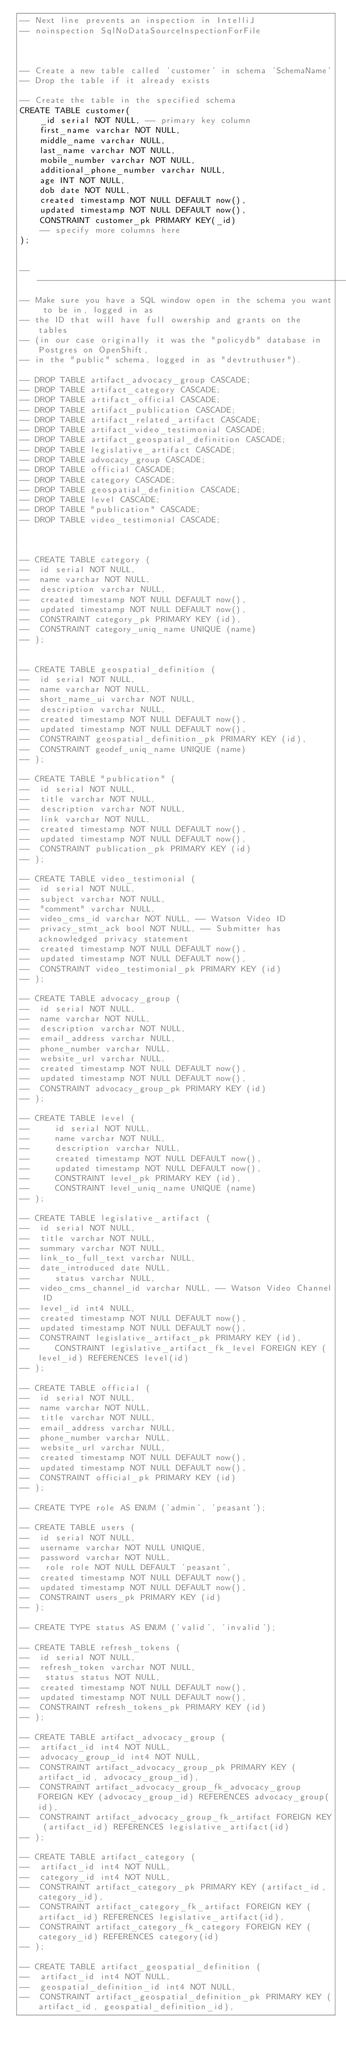<code> <loc_0><loc_0><loc_500><loc_500><_SQL_>-- Next line prevents an inspection in IntelliJ
-- noinspection SqlNoDataSourceInspectionForFile



-- Create a new table called 'customer' in schema 'SchemaName'
-- Drop the table if it already exists

-- Create the table in the specified schema
CREATE TABLE customer(
	_id serial NOT NULL, -- primary key column
	first_name varchar NOT NULL,
	middle_name varchar NULL,
	last_name varchar NOT NULL,
	mobile_number varchar NOT NULL,
	additional_phone_number varchar NULL,
	age INT NOT NULL,
	dob date NOT NULL,
	created timestamp NOT NULL DEFAULT now(),
	updated timestamp NOT NULL DEFAULT now(),
	CONSTRAINT customer_pk PRIMARY KEY(_id)
	-- specify more columns here
);


-- --------------------------------------------------------------------------------------------------------
-- Make sure you have a SQL window open in the schema you want to be in, logged in as
-- the ID that will have full owership and grants on the tables
-- (in our case originally it was the "policydb" database in Postgres on OpenShift,
-- in the "public" schema, logged in as "devtruthuser").

-- DROP TABLE artifact_advocacy_group CASCADE;
-- DROP TABLE artifact_category CASCADE;
-- DROP TABLE artifact_official CASCADE;
-- DROP TABLE artifact_publication CASCADE;
-- DROP TABLE artifact_related_artifact CASCADE;
-- DROP TABLE artifact_video_testimonial CASCADE;
-- DROP TABLE artifact_geospatial_definition CASCADE;
-- DROP TABLE legislative_artifact CASCADE;
-- DROP TABLE advocacy_group CASCADE;
-- DROP TABLE official CASCADE;
-- DROP TABLE category CASCADE;
-- DROP TABLE geospatial_definition CASCADE;
-- DROP TABLE level CASCADE;
-- DROP TABLE "publication" CASCADE;
-- DROP TABLE video_testimonial CASCADE;



-- CREATE TABLE category (
-- 	id serial NOT NULL,
-- 	name varchar NOT NULL,
-- 	description varchar NULL,
-- 	created timestamp NOT NULL DEFAULT now(),
-- 	updated timestamp NOT NULL DEFAULT now(),
-- 	CONSTRAINT category_pk PRIMARY KEY (id),
-- 	CONSTRAINT category_uniq_name UNIQUE (name)
-- );


-- CREATE TABLE geospatial_definition (
-- 	id serial NOT NULL,
-- 	name varchar NOT NULL,
-- 	short_name_ui varchar NOT NULL,
-- 	description varchar NULL,
-- 	created timestamp NOT NULL DEFAULT now(),
-- 	updated timestamp NOT NULL DEFAULT now(),
-- 	CONSTRAINT geospatial_definition_pk PRIMARY KEY (id),
-- 	CONSTRAINT geodef_uniq_name UNIQUE (name)
-- );

-- CREATE TABLE "publication" (
-- 	id serial NOT NULL,
-- 	title varchar NOT NULL,
-- 	description varchar NOT NULL,
-- 	link varchar NOT NULL,
-- 	created timestamp NOT NULL DEFAULT now(),
-- 	updated timestamp NOT NULL DEFAULT now(),
-- 	CONSTRAINT publication_pk PRIMARY KEY (id)
-- );

-- CREATE TABLE video_testimonial (
-- 	id serial NOT NULL,
-- 	subject varchar NOT NULL,
-- 	"comment" varchar NULL,
-- 	video_cms_id varchar NOT NULL, -- Watson Video ID
-- 	privacy_stmt_ack bool NOT NULL, -- Submitter has acknowledged privacy statement
-- 	created timestamp NOT NULL DEFAULT now(),
-- 	updated timestamp NOT NULL DEFAULT now(),
-- 	CONSTRAINT video_testimonial_pk PRIMARY KEY (id)
-- );

-- CREATE TABLE advocacy_group (
-- 	id serial NOT NULL,
-- 	name varchar NOT NULL,
-- 	description varchar NOT NULL,
-- 	email_address varchar NULL,
-- 	phone_number varchar NULL,
-- 	website_url varchar NULL,
-- 	created timestamp NOT NULL DEFAULT now(),
-- 	updated timestamp NOT NULL DEFAULT now(),
-- 	CONSTRAINT advocacy_group_pk PRIMARY KEY (id)
-- );

-- CREATE TABLE level (
--     id serial NOT NULL,
--     name varchar NOT NULL,
--     description varchar NULL,
--     created timestamp NOT NULL DEFAULT now(),
--     updated timestamp NOT NULL DEFAULT now(),
--     CONSTRAINT level_pk PRIMARY KEY (id),
--     CONSTRAINT level_uniq_name UNIQUE (name)
-- );

-- CREATE TABLE legislative_artifact (
-- 	id serial NOT NULL,
-- 	title varchar NOT NULL,
-- 	summary varchar NOT NULL,
-- 	link_to_full_text varchar NULL,
-- 	date_introduced date NULL,
--     status varchar NULL,
-- 	video_cms_channel_id varchar NULL, -- Watson Video Channel ID
-- 	level_id int4 NULL,
-- 	created timestamp NOT NULL DEFAULT now(),
-- 	updated timestamp NOT NULL DEFAULT now(),
-- 	CONSTRAINT legislative_artifact_pk PRIMARY KEY (id),
--     CONSTRAINT legislative_artifact_fk_level FOREIGN KEY (level_id) REFERENCES level(id)
-- );

-- CREATE TABLE official (
-- 	id serial NOT NULL,
-- 	name varchar NOT NULL,
-- 	title varchar NOT NULL,
-- 	email_address varchar NULL,
-- 	phone_number varchar NULL,
-- 	website_url varchar NULL,
-- 	created timestamp NOT NULL DEFAULT now(),
-- 	updated timestamp NOT NULL DEFAULT now(),
-- 	CONSTRAINT official_pk PRIMARY KEY (id)
-- );

-- CREATE TYPE role AS ENUM ('admin', 'peasant');

-- CREATE TABLE users (
-- 	id serial NOT NULL,
-- 	username varchar NOT NULL UNIQUE,
-- 	password varchar NOT NULL,
--   role role NOT NULL DEFAULT 'peasant',
-- 	created timestamp NOT NULL DEFAULT now(),
-- 	updated timestamp NOT NULL DEFAULT now(),
-- 	CONSTRAINT users_pk PRIMARY KEY (id)
-- );

-- CREATE TYPE status AS ENUM ('valid', 'invalid');

-- CREATE TABLE refresh_tokens (
-- 	id serial NOT NULL,
-- 	refresh_token varchar NOT NULL,
--   status status NOT NULL,
-- 	created timestamp NOT NULL DEFAULT now(),
-- 	updated timestamp NOT NULL DEFAULT now(),
-- 	CONSTRAINT refresh_tokens_pk PRIMARY KEY (id)
-- );

-- CREATE TABLE artifact_advocacy_group (
-- 	artifact_id int4 NOT NULL,
-- 	advocacy_group_id int4 NOT NULL,
-- 	CONSTRAINT artifact_advocacy_group_pk PRIMARY KEY (artifact_id, advocacy_group_id),
-- 	CONSTRAINT artifact_advocacy_group_fk_advocacy_group FOREIGN KEY (advocacy_group_id) REFERENCES advocacy_group(id),
-- 	CONSTRAINT artifact_advocacy_group_fk_artifact FOREIGN KEY (artifact_id) REFERENCES legislative_artifact(id)
-- );

-- CREATE TABLE artifact_category (
-- 	artifact_id int4 NOT NULL,
-- 	category_id int4 NOT NULL,
-- 	CONSTRAINT artifact_category_pk PRIMARY KEY (artifact_id, category_id),
-- 	CONSTRAINT artifact_category_fk_artifact FOREIGN KEY (artifact_id) REFERENCES legislative_artifact(id),
-- 	CONSTRAINT artifact_category_fk_category FOREIGN KEY (category_id) REFERENCES category(id)
-- );

-- CREATE TABLE artifact_geospatial_definition (
-- 	artifact_id int4 NOT NULL,
-- 	geospatial_definition_id int4 NOT NULL,
-- 	CONSTRAINT artifact_geospatial_definition_pk PRIMARY KEY (artifact_id, geospatial_definition_id),</code> 